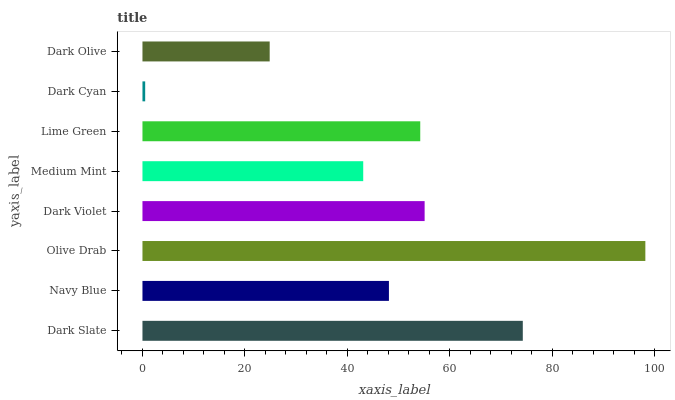Is Dark Cyan the minimum?
Answer yes or no. Yes. Is Olive Drab the maximum?
Answer yes or no. Yes. Is Navy Blue the minimum?
Answer yes or no. No. Is Navy Blue the maximum?
Answer yes or no. No. Is Dark Slate greater than Navy Blue?
Answer yes or no. Yes. Is Navy Blue less than Dark Slate?
Answer yes or no. Yes. Is Navy Blue greater than Dark Slate?
Answer yes or no. No. Is Dark Slate less than Navy Blue?
Answer yes or no. No. Is Lime Green the high median?
Answer yes or no. Yes. Is Navy Blue the low median?
Answer yes or no. Yes. Is Dark Violet the high median?
Answer yes or no. No. Is Dark Cyan the low median?
Answer yes or no. No. 